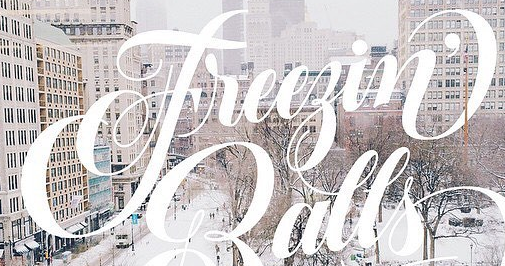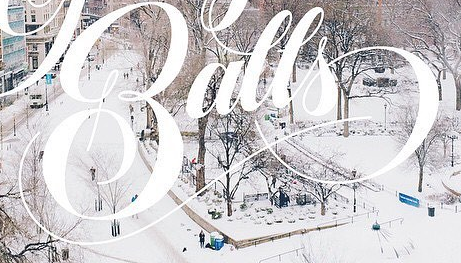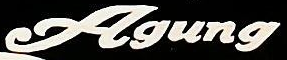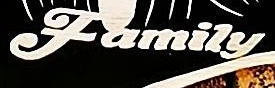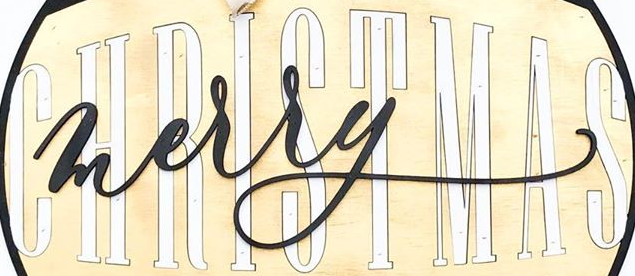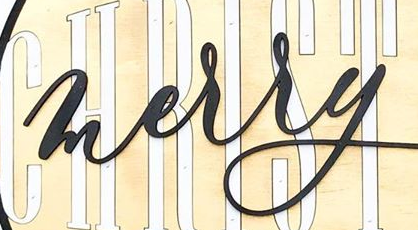What words are shown in these images in order, separated by a semicolon? Freegin'; Balls; Agung; Family; CHRISTMAS; merry 